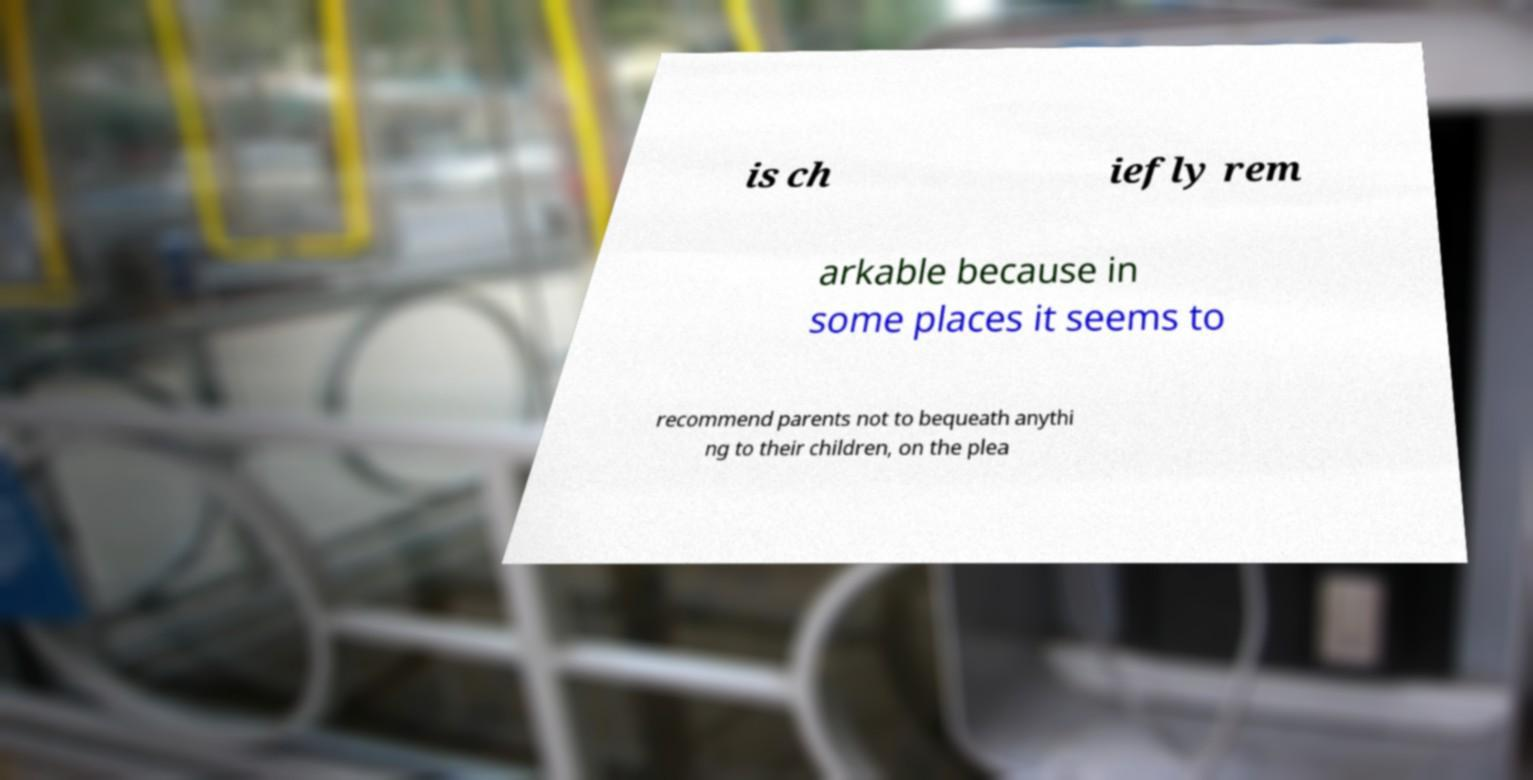Please identify and transcribe the text found in this image. is ch iefly rem arkable because in some places it seems to recommend parents not to bequeath anythi ng to their children, on the plea 